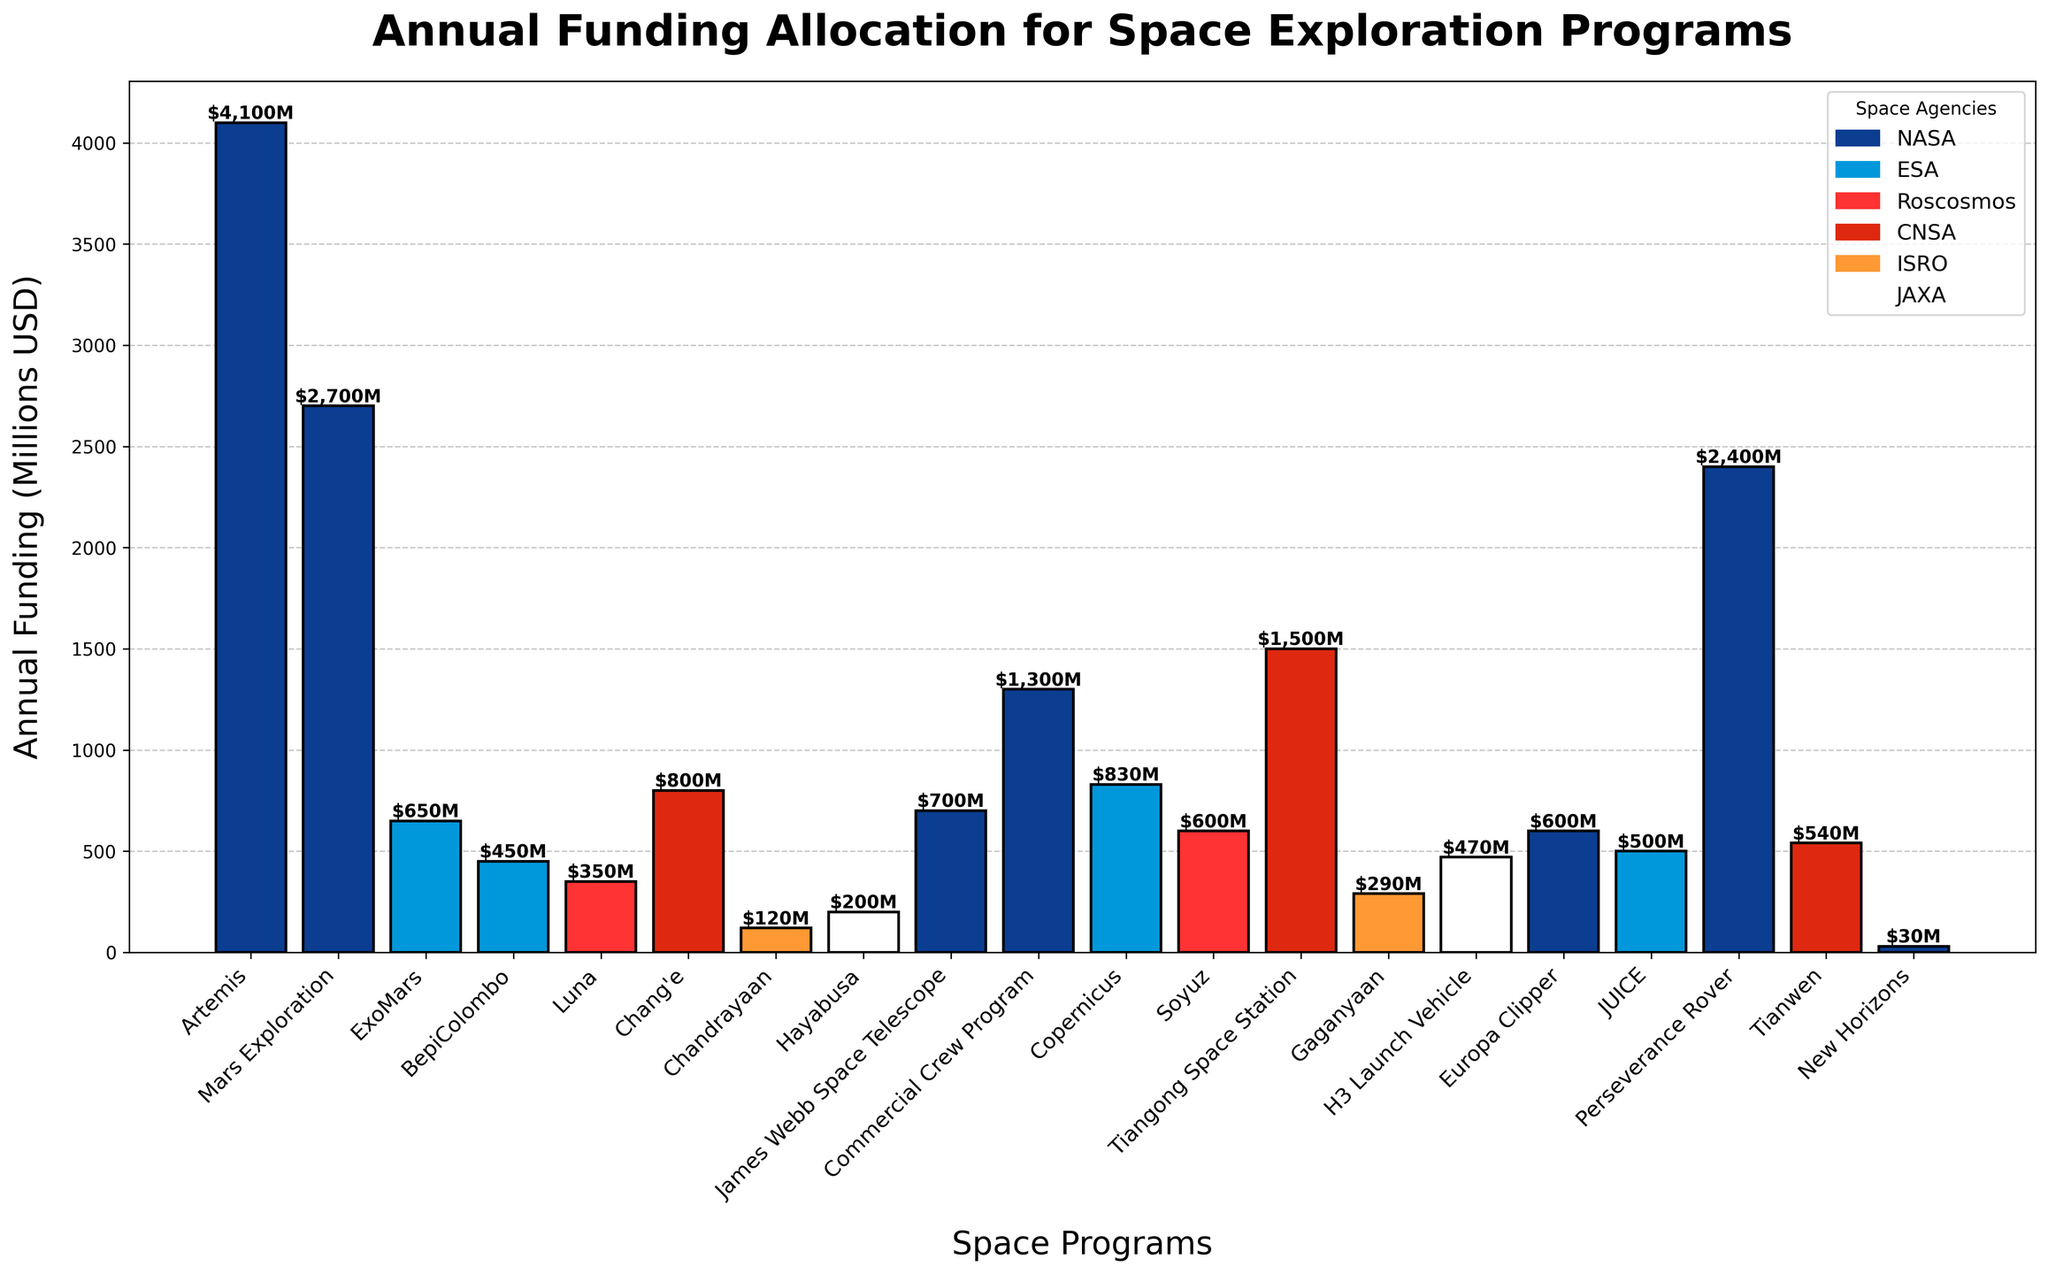What is the total annual funding allocated to NASA's programs? To find the total annual funding allocated to NASA, sum up the funding amounts of all NASA's programs: Artemis (4100) + Mars Exploration (2700) + James Webb Space Telescope (700) + Commercial Crew Program (1300) + Europa Clipper (600) + Perseverance Rover (2400) + New Horizons (30). This results in 4100 + 2700 + 700 + 1300 + 600 + 2400 + 30 = 11830.
Answer: 11830 Which program has the highest annual funding and which agency does it belong to? To identify the program with the highest funding, look for the tallest bar in the chart. The tallest bar represents the Artemis program with an annual funding of 4100 million USD. This program belongs to NASA.
Answer: Artemis, NASA How does the funding for ESA's Copernicus program compare to CNSA's Tiangong Space Station program? To compare the funding, look at the bars for both programs. The Copernicus program has a funding of 830 million USD, whereas the Tiangong Space Station has a funding of 1500 million USD. Tiangong Space Station's funding is greater.
Answer: Tiangong Space Station has higher funding What is the average annual funding for all the space exploration programs? To find the average funding, sum up all the funding amounts and divide by the number of programs. The total funding is 4100 + 2700 + 650 + 450 + 350 + 800 + 120 + 200 + 700 + 1300 + 830 + 600 + 1500 + 290 + 470 + 600 + 500 + 2400 + 540 + 30 = 19930 million USD. There are 20 programs. Average funding = 19930 / 20 = 996.5.
Answer: 996.5 Which agency has the fewest programs listed, and what is one of the programs they fund? Look at the number of programs per agency. ISRO has the fewest programs with 2 listed (Chandrayaan, Gaganyaan). One of the programs funded by ISRO is Chandrayaan.
Answer: ISRO, Chandrayaan How does the funding for NASA's Mars Exploration compare to the funding for CNSA's Chang'e and JAXA's Hayabusa combined? Sum the funding for Chang'e and Hayabusa: Chang'e (800) + Hayabusa (200) = 1000. Compare this to Mars Exploration's funding of 2700. Mars Exploration's funding is greater.
Answer: Mars Exploration's funding is greater How much more funding does NASA's Perseverance Rover receive compared to ESA's ExoMars program? Subtract the funding of ExoMars (650) from the funding of Perseverance Rover (2400): 2400 - 650 = 1750. Perseverance Rover receives 1750 million USD more funding than ExoMars.
Answer: 1750 What is the median value of the annual funding among all programs? To find the median, arrange the funding amounts in ascending order and find the middle value(s). The sorted funding amounts: 30, 120, 200, 290, 350, 450, 470, 500, 540, 600, 600, 650, 700, 800, 830, 1300, 1500, 2400, 2700, 4100. With 20 values, median is the average of 10th and 11th values: (600 + 600) / 2 = 600.
Answer: 600 How many programs have an annual funding below 500 million USD? Count the number of bars representing funding amounts below 500 million USD: Chandrayaan (120), Hayabusa (200), Gaganyaan (290), Luna (350), BepiColombo (450). There are 5 programs with funding below 500 million USD.
Answer: 5 